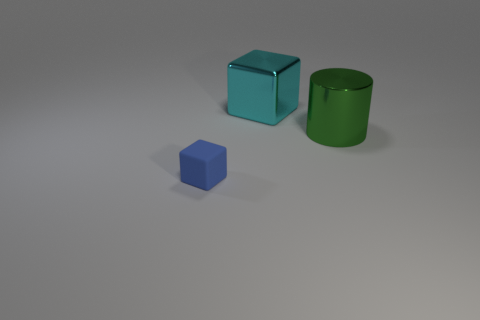Is there any other thing that has the same size as the blue matte cube?
Offer a very short reply. No. There is a big cyan block; what number of blue rubber things are behind it?
Offer a very short reply. 0. There is a cube that is behind the large metal thing in front of the cube behind the small block; what is its size?
Give a very brief answer. Large. Do the blue rubber object and the metallic object that is in front of the large cyan shiny cube have the same shape?
Keep it short and to the point. No. There is a object that is the same material as the large green cylinder; what size is it?
Ensure brevity in your answer.  Large. Is there any other thing that is the same color as the tiny matte thing?
Make the answer very short. No. What material is the cube that is behind the object on the right side of the cube on the right side of the blue object?
Offer a terse response. Metal. What number of metal things are big green things or tiny objects?
Provide a short and direct response. 1. Does the tiny matte thing have the same color as the big metallic cube?
Offer a very short reply. No. Is there anything else that is the same material as the blue object?
Your answer should be very brief. No. 